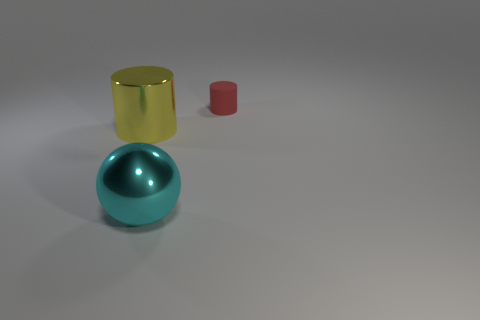Add 3 red rubber cylinders. How many objects exist? 6 Subtract all cylinders. How many objects are left? 1 Add 3 large cyan metal objects. How many large cyan metal objects are left? 4 Add 2 small red rubber cylinders. How many small red rubber cylinders exist? 3 Subtract 0 gray blocks. How many objects are left? 3 Subtract all cyan shiny objects. Subtract all big yellow metallic things. How many objects are left? 1 